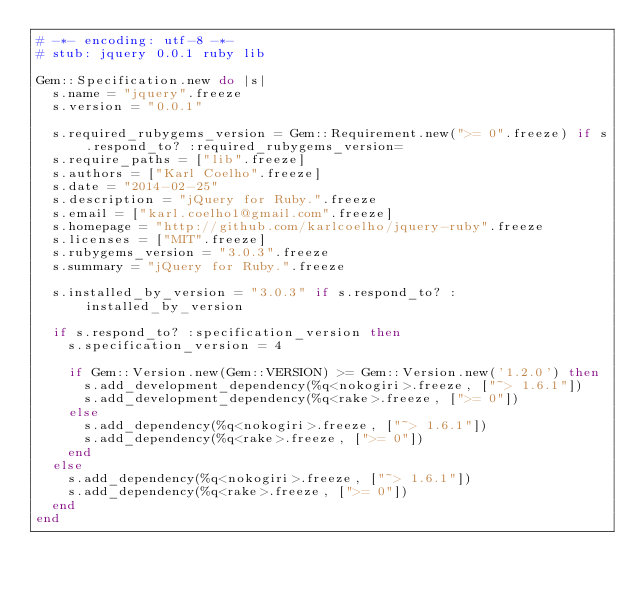Convert code to text. <code><loc_0><loc_0><loc_500><loc_500><_Ruby_># -*- encoding: utf-8 -*-
# stub: jquery 0.0.1 ruby lib

Gem::Specification.new do |s|
  s.name = "jquery".freeze
  s.version = "0.0.1"

  s.required_rubygems_version = Gem::Requirement.new(">= 0".freeze) if s.respond_to? :required_rubygems_version=
  s.require_paths = ["lib".freeze]
  s.authors = ["Karl Coelho".freeze]
  s.date = "2014-02-25"
  s.description = "jQuery for Ruby.".freeze
  s.email = ["karl.coelho1@gmail.com".freeze]
  s.homepage = "http://github.com/karlcoelho/jquery-ruby".freeze
  s.licenses = ["MIT".freeze]
  s.rubygems_version = "3.0.3".freeze
  s.summary = "jQuery for Ruby.".freeze

  s.installed_by_version = "3.0.3" if s.respond_to? :installed_by_version

  if s.respond_to? :specification_version then
    s.specification_version = 4

    if Gem::Version.new(Gem::VERSION) >= Gem::Version.new('1.2.0') then
      s.add_development_dependency(%q<nokogiri>.freeze, ["~> 1.6.1"])
      s.add_development_dependency(%q<rake>.freeze, [">= 0"])
    else
      s.add_dependency(%q<nokogiri>.freeze, ["~> 1.6.1"])
      s.add_dependency(%q<rake>.freeze, [">= 0"])
    end
  else
    s.add_dependency(%q<nokogiri>.freeze, ["~> 1.6.1"])
    s.add_dependency(%q<rake>.freeze, [">= 0"])
  end
end
</code> 